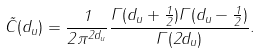<formula> <loc_0><loc_0><loc_500><loc_500>\tilde { C } ( d _ { u } ) = \frac { 1 } { 2 \pi ^ { 2 d _ { u } } } \frac { \Gamma ( d _ { u } + \frac { 1 } { 2 } ) \Gamma ( d _ { u } - \frac { 1 } { 2 } ) } { \Gamma ( 2 d _ { u } ) } .</formula> 